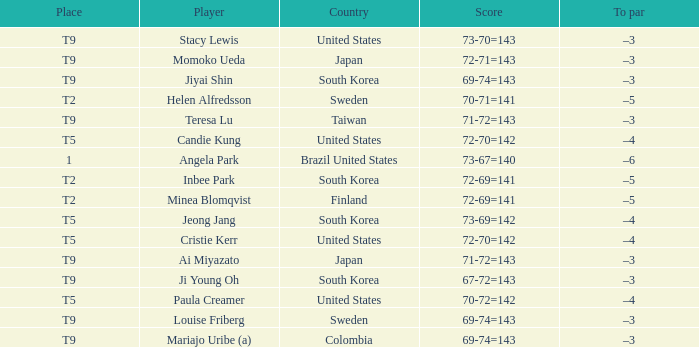What did taiwan achieve? 71-72=143. 